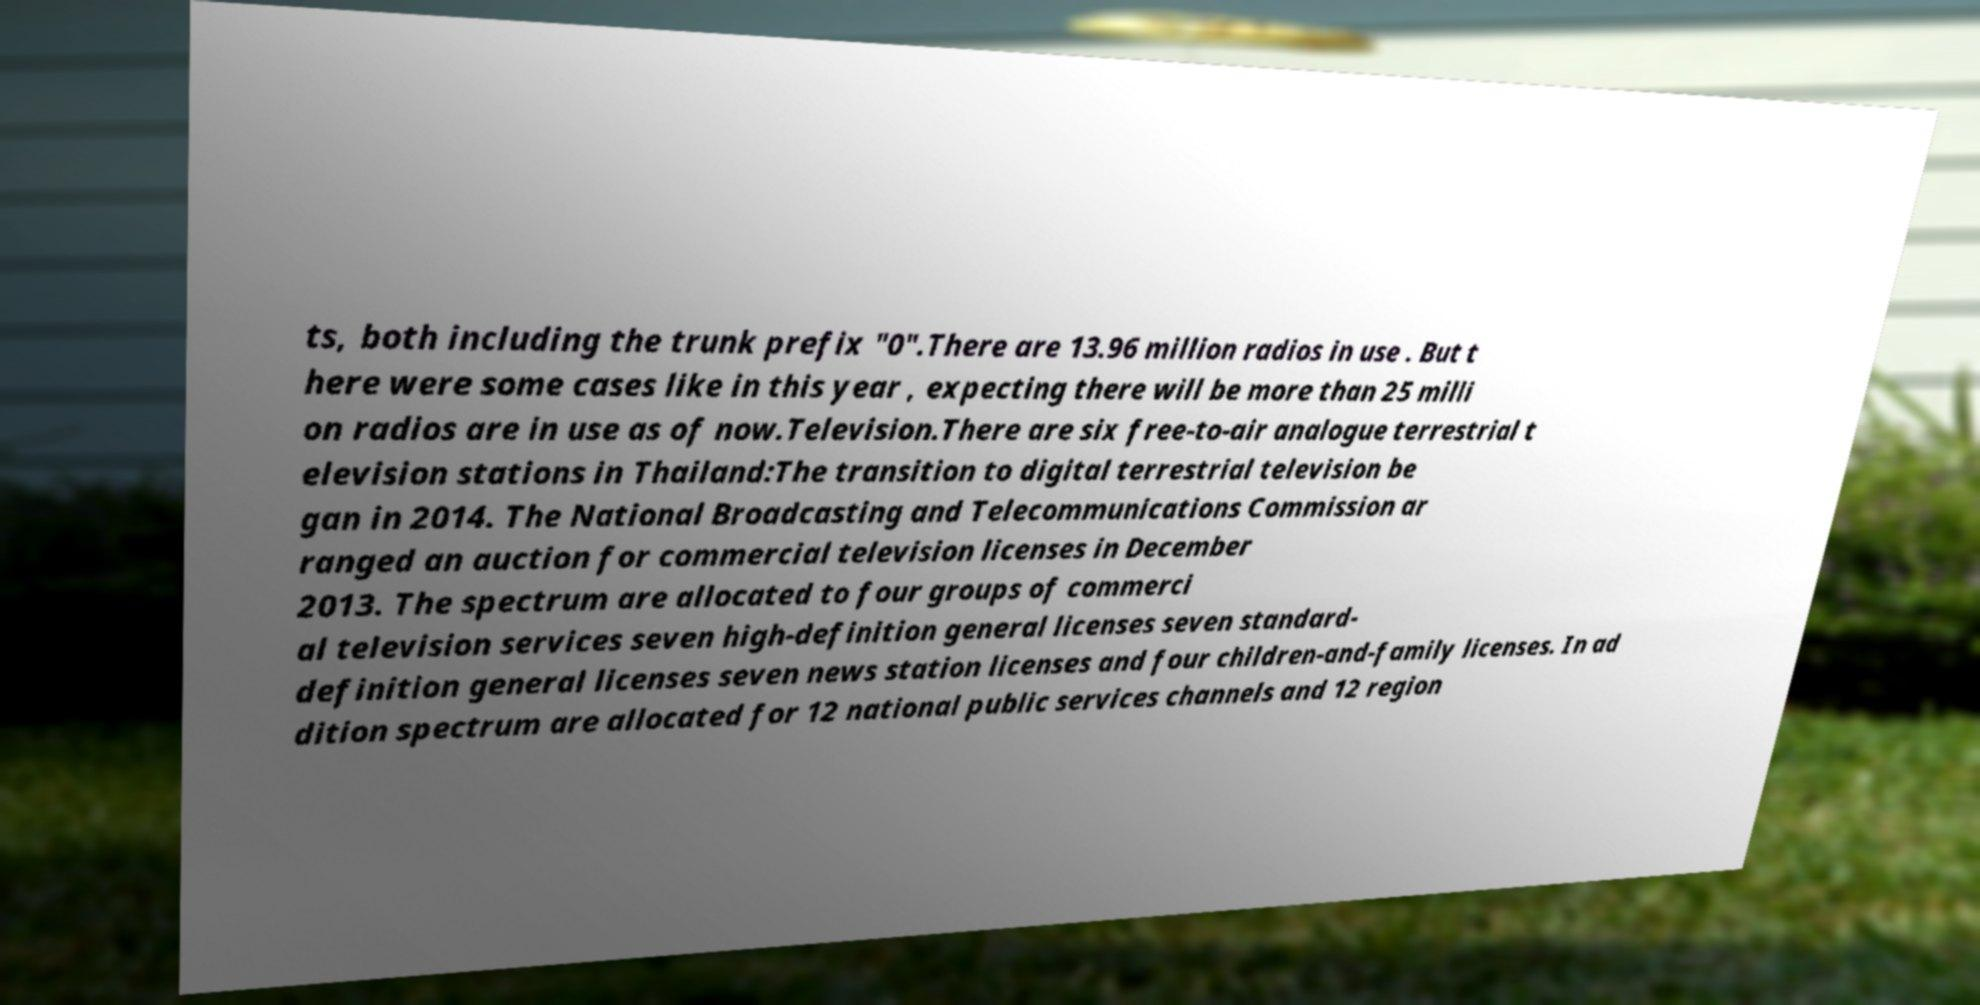For documentation purposes, I need the text within this image transcribed. Could you provide that? ts, both including the trunk prefix "0".There are 13.96 million radios in use . But t here were some cases like in this year , expecting there will be more than 25 milli on radios are in use as of now.Television.There are six free-to-air analogue terrestrial t elevision stations in Thailand:The transition to digital terrestrial television be gan in 2014. The National Broadcasting and Telecommunications Commission ar ranged an auction for commercial television licenses in December 2013. The spectrum are allocated to four groups of commerci al television services seven high-definition general licenses seven standard- definition general licenses seven news station licenses and four children-and-family licenses. In ad dition spectrum are allocated for 12 national public services channels and 12 region 